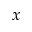Convert formula to latex. <formula><loc_0><loc_0><loc_500><loc_500>x</formula> 